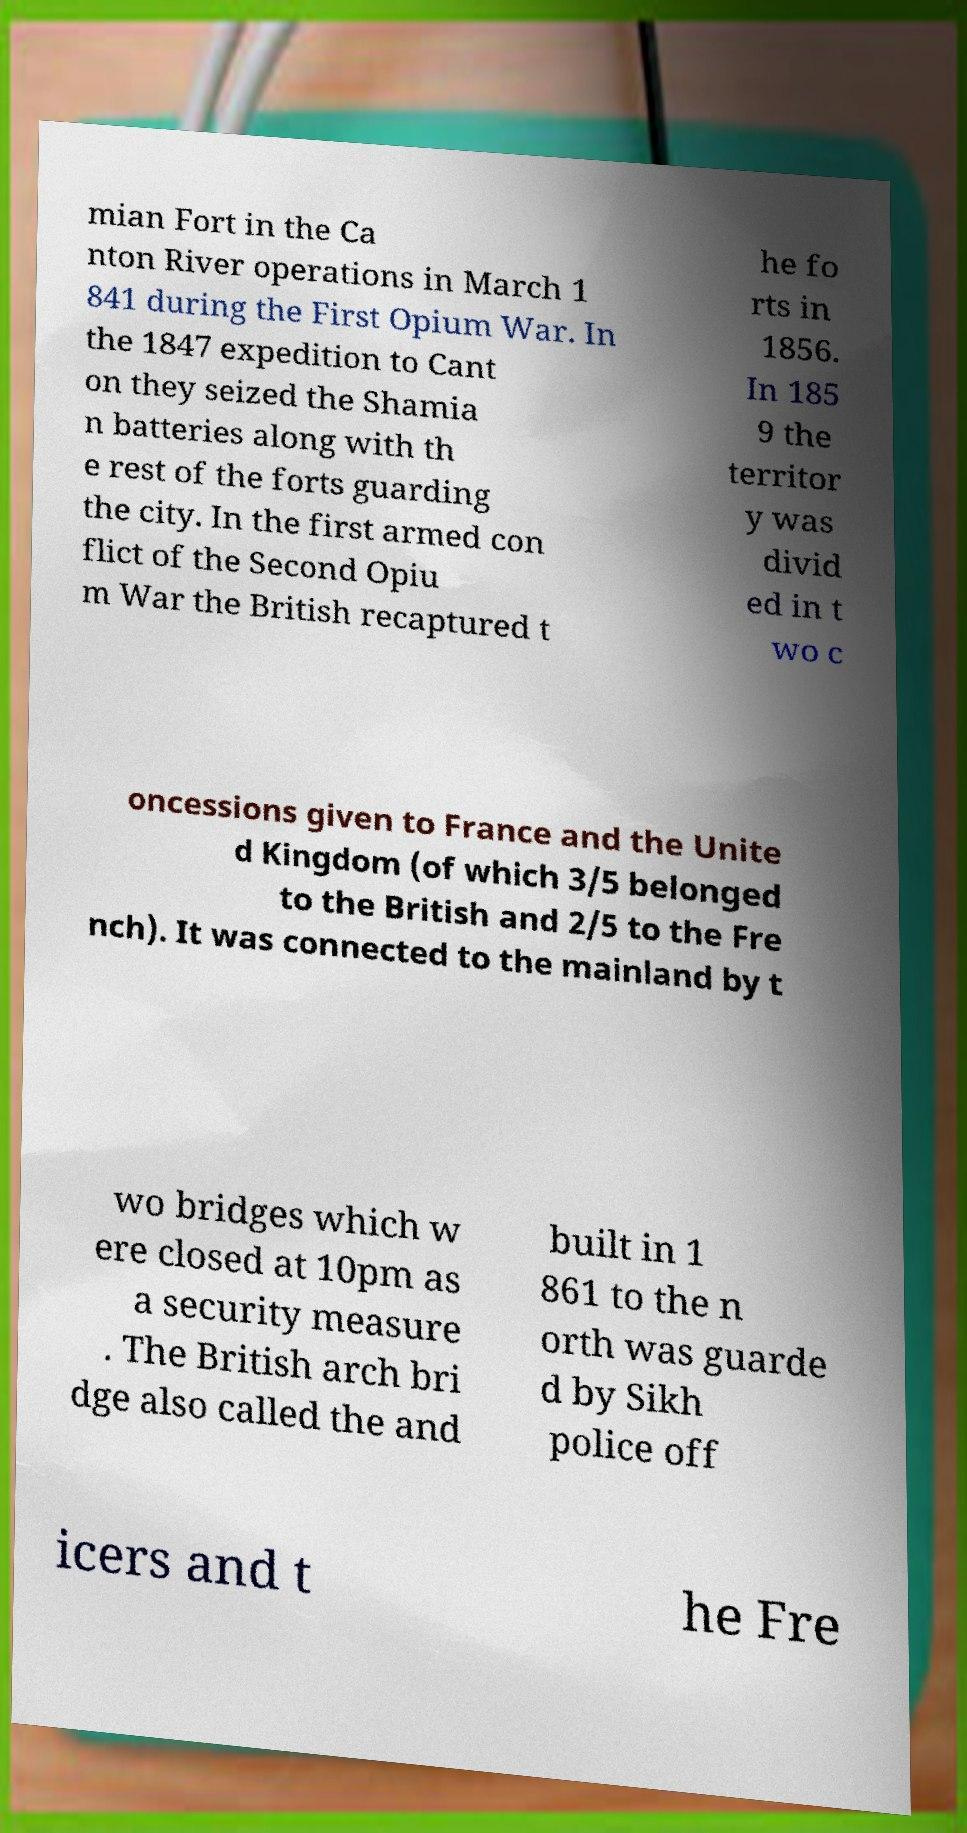Could you extract and type out the text from this image? mian Fort in the Ca nton River operations in March 1 841 during the First Opium War. In the 1847 expedition to Cant on they seized the Shamia n batteries along with th e rest of the forts guarding the city. In the first armed con flict of the Second Opiu m War the British recaptured t he fo rts in 1856. In 185 9 the territor y was divid ed in t wo c oncessions given to France and the Unite d Kingdom (of which 3/5 belonged to the British and 2/5 to the Fre nch). It was connected to the mainland by t wo bridges which w ere closed at 10pm as a security measure . The British arch bri dge also called the and built in 1 861 to the n orth was guarde d by Sikh police off icers and t he Fre 